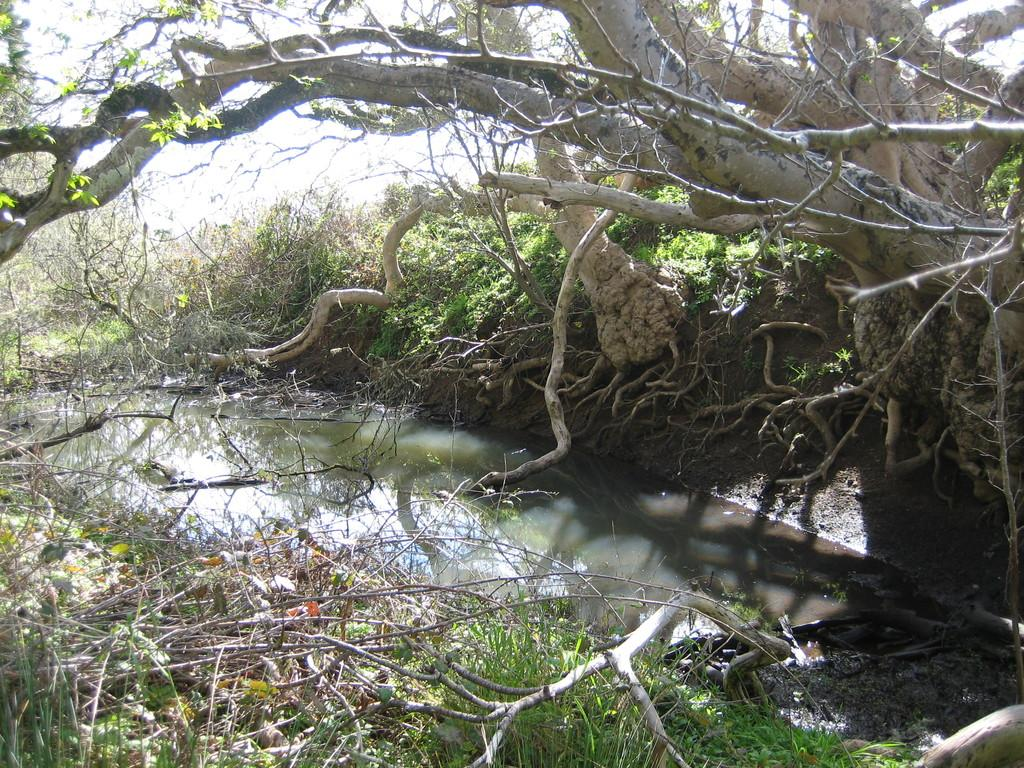What is located in the right top corner of the image? There is a tree in the right top corner of the image. What is below the tree in the image? There is water below the tree in the image. What type of vegetation is present on either side of the tree? There are plants on either side of the tree. Can you see a crowd of people playing guitar in the image? There is no crowd of people playing guitar in the image. How many quarters can be seen in the image? There are no quarters present in the image. 